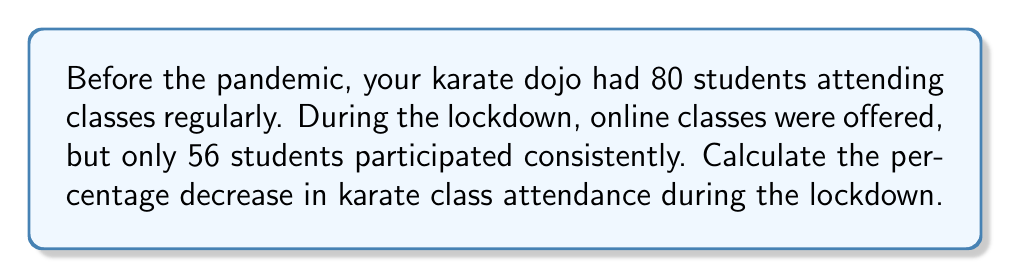Provide a solution to this math problem. To calculate the percentage decrease in attendance, we'll follow these steps:

1. Calculate the difference in attendance:
   $$\text{Difference} = \text{Initial attendance} - \text{Lockdown attendance}$$
   $$\text{Difference} = 80 - 56 = 24$$

2. Calculate the percentage decrease:
   $$\text{Percentage decrease} = \frac{\text{Difference}}{\text{Initial attendance}} \times 100\%$$
   $$\text{Percentage decrease} = \frac{24}{80} \times 100\%$$

3. Simplify the fraction:
   $$\frac{24}{80} = \frac{3}{10} = 0.3$$

4. Calculate the final percentage:
   $$0.3 \times 100\% = 30\%$$

Therefore, the percentage decrease in karate class attendance during the lockdown is 30%.
Answer: 30% 